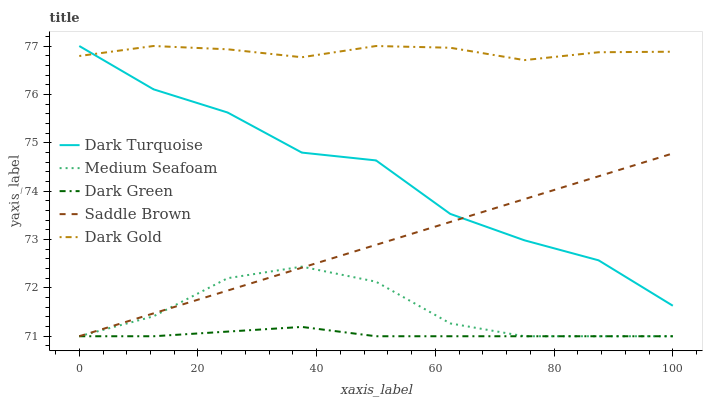Does Dark Green have the minimum area under the curve?
Answer yes or no. Yes. Does Dark Gold have the maximum area under the curve?
Answer yes or no. Yes. Does Dark Turquoise have the minimum area under the curve?
Answer yes or no. No. Does Dark Turquoise have the maximum area under the curve?
Answer yes or no. No. Is Saddle Brown the smoothest?
Answer yes or no. Yes. Is Dark Turquoise the roughest?
Answer yes or no. Yes. Is Dark Gold the smoothest?
Answer yes or no. No. Is Dark Gold the roughest?
Answer yes or no. No. Does Saddle Brown have the lowest value?
Answer yes or no. Yes. Does Dark Turquoise have the lowest value?
Answer yes or no. No. Does Dark Gold have the highest value?
Answer yes or no. Yes. Does Medium Seafoam have the highest value?
Answer yes or no. No. Is Dark Green less than Dark Gold?
Answer yes or no. Yes. Is Dark Gold greater than Medium Seafoam?
Answer yes or no. Yes. Does Dark Green intersect Saddle Brown?
Answer yes or no. Yes. Is Dark Green less than Saddle Brown?
Answer yes or no. No. Is Dark Green greater than Saddle Brown?
Answer yes or no. No. Does Dark Green intersect Dark Gold?
Answer yes or no. No. 